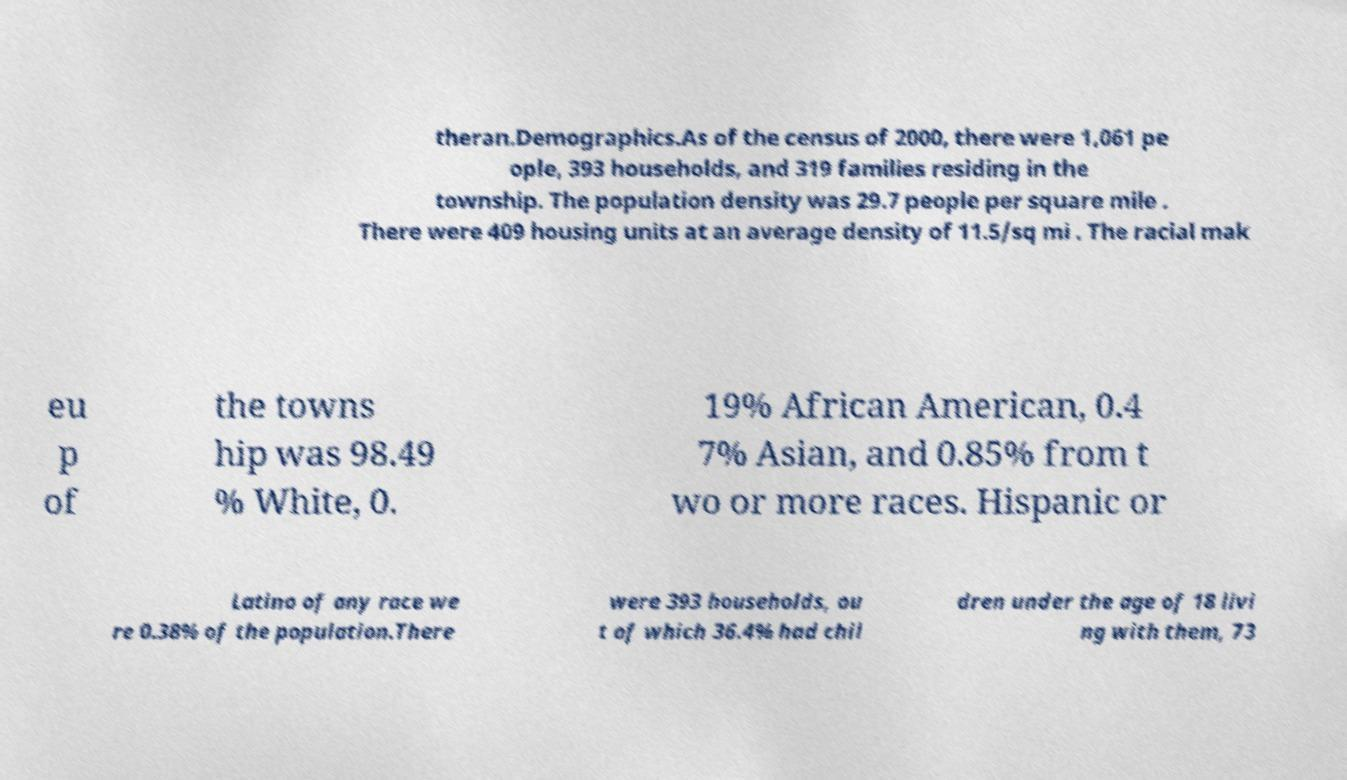There's text embedded in this image that I need extracted. Can you transcribe it verbatim? theran.Demographics.As of the census of 2000, there were 1,061 pe ople, 393 households, and 319 families residing in the township. The population density was 29.7 people per square mile . There were 409 housing units at an average density of 11.5/sq mi . The racial mak eu p of the towns hip was 98.49 % White, 0. 19% African American, 0.4 7% Asian, and 0.85% from t wo or more races. Hispanic or Latino of any race we re 0.38% of the population.There were 393 households, ou t of which 36.4% had chil dren under the age of 18 livi ng with them, 73 